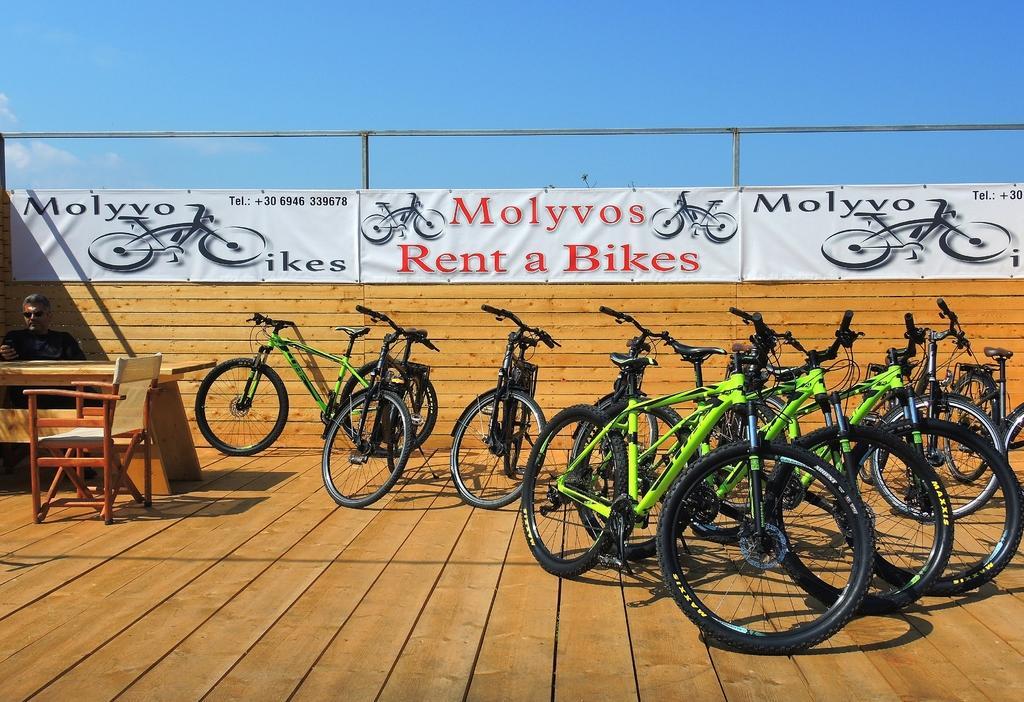How would you summarize this image in a sentence or two? In this image we can see many bicycles. There are few advertising banners in the image. There is a person at the left side of the image. There is a table and a chair at the left side of the image. We can see the sky in the image. 